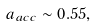<formula> <loc_0><loc_0><loc_500><loc_500>a _ { a c c } \sim 0 . 5 5 ,</formula> 